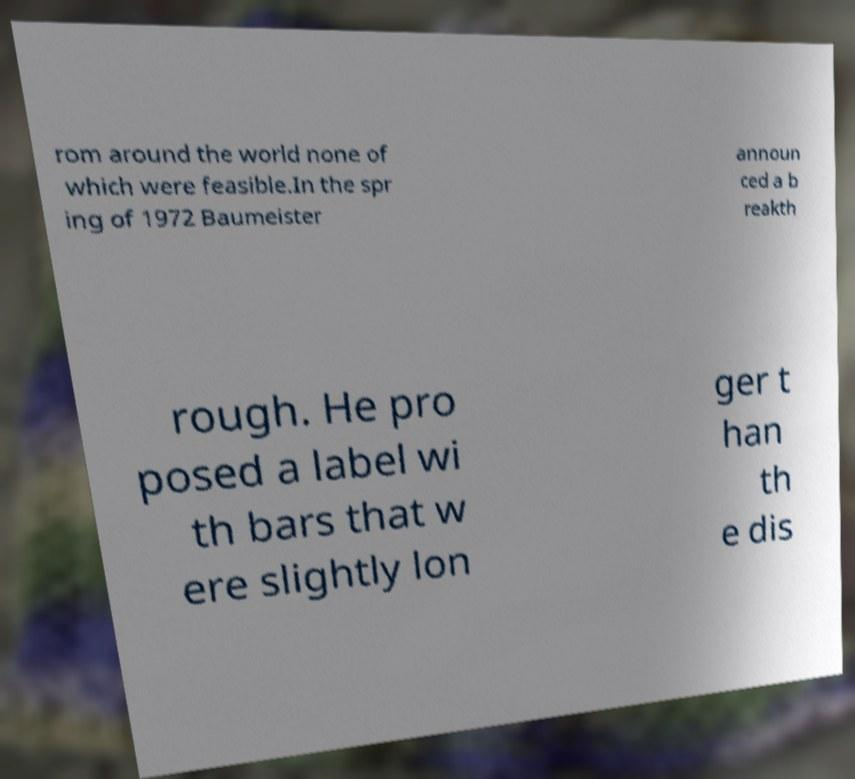For documentation purposes, I need the text within this image transcribed. Could you provide that? rom around the world none of which were feasible.In the spr ing of 1972 Baumeister announ ced a b reakth rough. He pro posed a label wi th bars that w ere slightly lon ger t han th e dis 